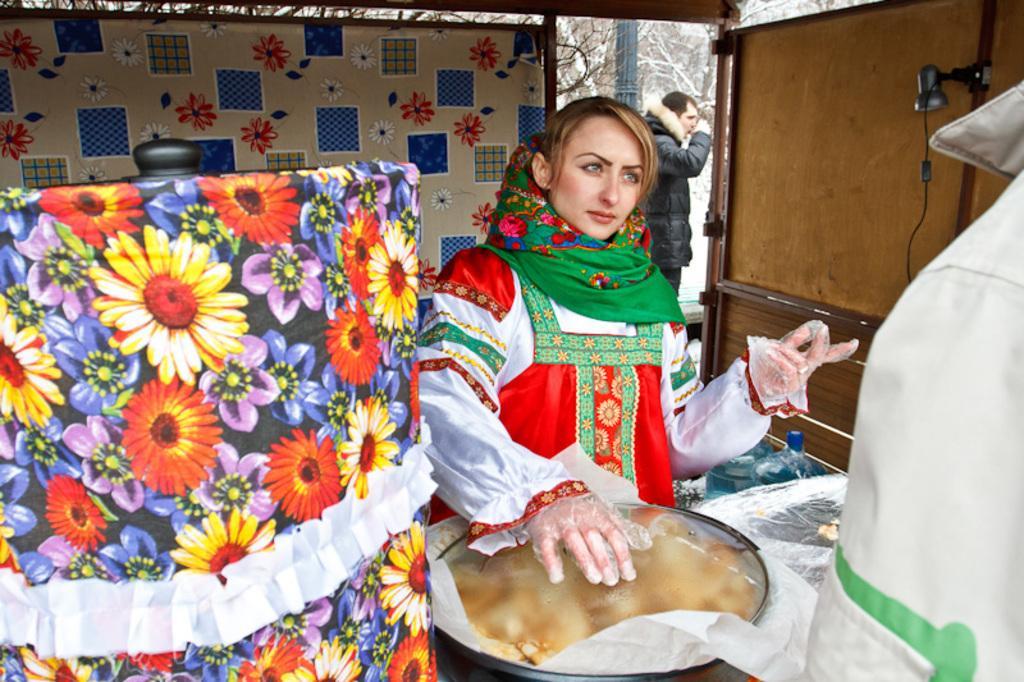Could you give a brief overview of what you see in this image? In this image there is a woman wearing hand gloves and covering the lid of a container. In the background there is some person. There is also a curtain with flowers. On the right there is a wooden wall. On the left there is an object with cover as flowers. In the background we can see some trees covered with snow. 